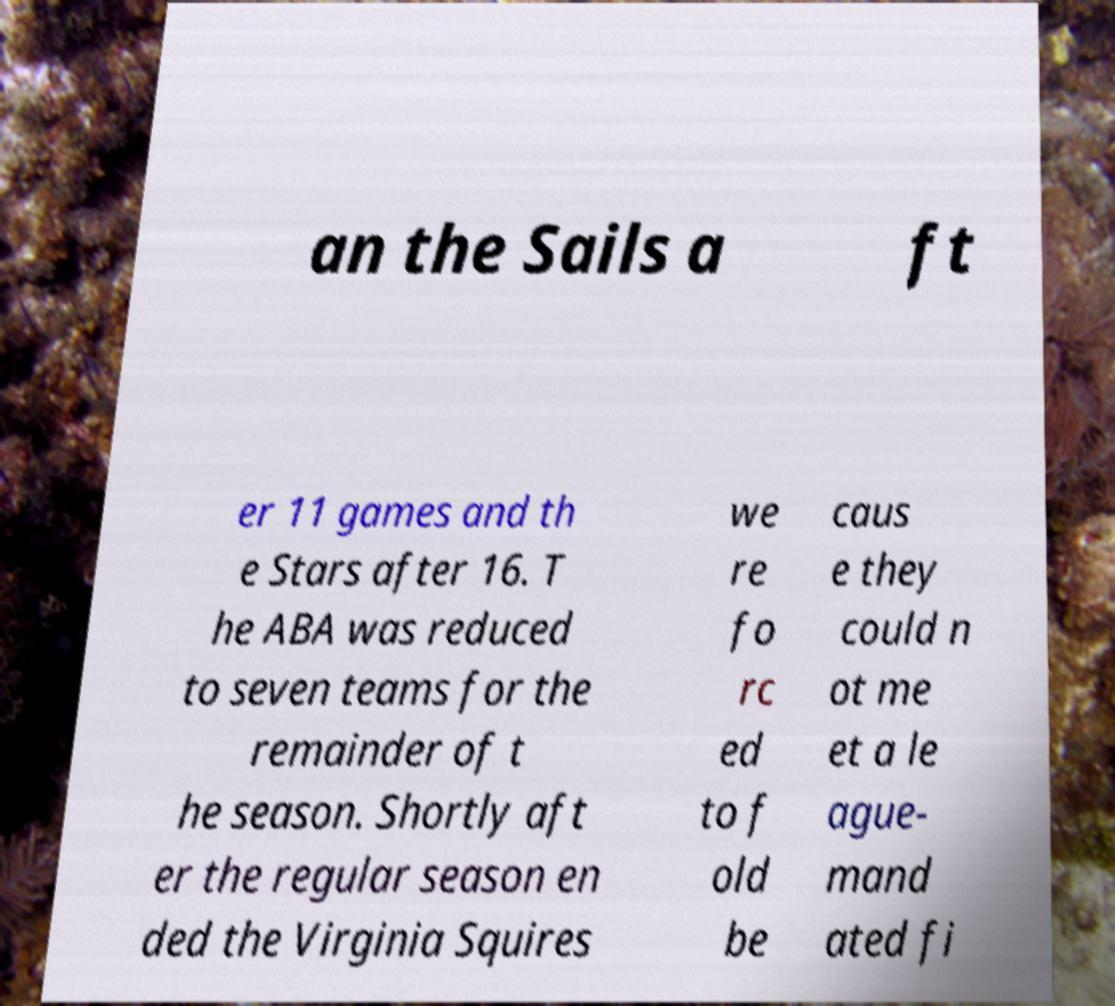There's text embedded in this image that I need extracted. Can you transcribe it verbatim? an the Sails a ft er 11 games and th e Stars after 16. T he ABA was reduced to seven teams for the remainder of t he season. Shortly aft er the regular season en ded the Virginia Squires we re fo rc ed to f old be caus e they could n ot me et a le ague- mand ated fi 